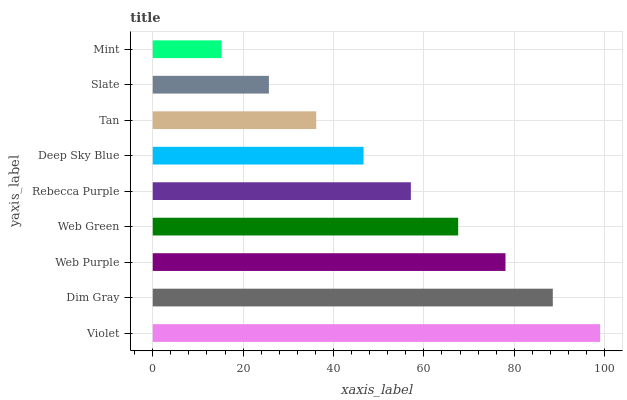Is Mint the minimum?
Answer yes or no. Yes. Is Violet the maximum?
Answer yes or no. Yes. Is Dim Gray the minimum?
Answer yes or no. No. Is Dim Gray the maximum?
Answer yes or no. No. Is Violet greater than Dim Gray?
Answer yes or no. Yes. Is Dim Gray less than Violet?
Answer yes or no. Yes. Is Dim Gray greater than Violet?
Answer yes or no. No. Is Violet less than Dim Gray?
Answer yes or no. No. Is Rebecca Purple the high median?
Answer yes or no. Yes. Is Rebecca Purple the low median?
Answer yes or no. Yes. Is Web Purple the high median?
Answer yes or no. No. Is Web Purple the low median?
Answer yes or no. No. 